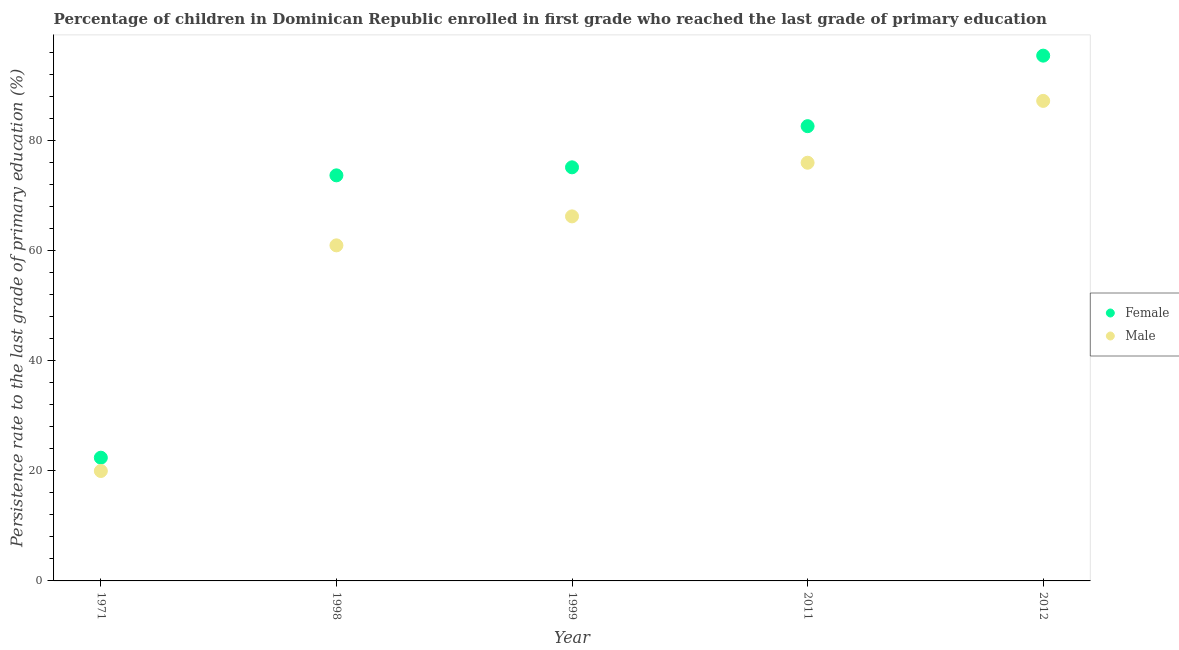What is the persistence rate of male students in 1971?
Keep it short and to the point. 19.98. Across all years, what is the maximum persistence rate of male students?
Provide a short and direct response. 87.27. Across all years, what is the minimum persistence rate of female students?
Provide a succinct answer. 22.4. In which year was the persistence rate of male students maximum?
Provide a succinct answer. 2012. What is the total persistence rate of male students in the graph?
Your response must be concise. 310.58. What is the difference between the persistence rate of female students in 1998 and that in 1999?
Make the answer very short. -1.46. What is the difference between the persistence rate of female students in 1999 and the persistence rate of male students in 1998?
Offer a terse response. 14.19. What is the average persistence rate of female students per year?
Ensure brevity in your answer.  69.9. In the year 1998, what is the difference between the persistence rate of male students and persistence rate of female students?
Offer a very short reply. -12.73. What is the ratio of the persistence rate of male students in 1971 to that in 1999?
Your answer should be compact. 0.3. Is the persistence rate of female students in 1971 less than that in 2011?
Keep it short and to the point. Yes. What is the difference between the highest and the second highest persistence rate of female students?
Make the answer very short. 12.82. What is the difference between the highest and the lowest persistence rate of female students?
Your answer should be compact. 73.1. Is the persistence rate of male students strictly greater than the persistence rate of female students over the years?
Your answer should be compact. No. Is the persistence rate of female students strictly less than the persistence rate of male students over the years?
Keep it short and to the point. No. How many years are there in the graph?
Ensure brevity in your answer.  5. Does the graph contain any zero values?
Provide a short and direct response. No. Does the graph contain grids?
Make the answer very short. No. Where does the legend appear in the graph?
Offer a terse response. Center right. How are the legend labels stacked?
Provide a succinct answer. Vertical. What is the title of the graph?
Offer a terse response. Percentage of children in Dominican Republic enrolled in first grade who reached the last grade of primary education. What is the label or title of the X-axis?
Make the answer very short. Year. What is the label or title of the Y-axis?
Give a very brief answer. Persistence rate to the last grade of primary education (%). What is the Persistence rate to the last grade of primary education (%) in Female in 1971?
Ensure brevity in your answer.  22.4. What is the Persistence rate to the last grade of primary education (%) of Male in 1971?
Provide a short and direct response. 19.98. What is the Persistence rate to the last grade of primary education (%) in Female in 1998?
Provide a short and direct response. 73.74. What is the Persistence rate to the last grade of primary education (%) of Male in 1998?
Your answer should be compact. 61.01. What is the Persistence rate to the last grade of primary education (%) of Female in 1999?
Your response must be concise. 75.2. What is the Persistence rate to the last grade of primary education (%) of Male in 1999?
Your answer should be very brief. 66.28. What is the Persistence rate to the last grade of primary education (%) of Female in 2011?
Your response must be concise. 82.68. What is the Persistence rate to the last grade of primary education (%) of Male in 2011?
Your response must be concise. 76.03. What is the Persistence rate to the last grade of primary education (%) of Female in 2012?
Give a very brief answer. 95.5. What is the Persistence rate to the last grade of primary education (%) of Male in 2012?
Offer a terse response. 87.27. Across all years, what is the maximum Persistence rate to the last grade of primary education (%) of Female?
Your response must be concise. 95.5. Across all years, what is the maximum Persistence rate to the last grade of primary education (%) of Male?
Your answer should be compact. 87.27. Across all years, what is the minimum Persistence rate to the last grade of primary education (%) in Female?
Make the answer very short. 22.4. Across all years, what is the minimum Persistence rate to the last grade of primary education (%) in Male?
Provide a succinct answer. 19.98. What is the total Persistence rate to the last grade of primary education (%) in Female in the graph?
Give a very brief answer. 349.51. What is the total Persistence rate to the last grade of primary education (%) in Male in the graph?
Provide a succinct answer. 310.58. What is the difference between the Persistence rate to the last grade of primary education (%) in Female in 1971 and that in 1998?
Offer a very short reply. -51.33. What is the difference between the Persistence rate to the last grade of primary education (%) of Male in 1971 and that in 1998?
Offer a terse response. -41.03. What is the difference between the Persistence rate to the last grade of primary education (%) in Female in 1971 and that in 1999?
Your response must be concise. -52.79. What is the difference between the Persistence rate to the last grade of primary education (%) in Male in 1971 and that in 1999?
Ensure brevity in your answer.  -46.3. What is the difference between the Persistence rate to the last grade of primary education (%) in Female in 1971 and that in 2011?
Keep it short and to the point. -60.27. What is the difference between the Persistence rate to the last grade of primary education (%) of Male in 1971 and that in 2011?
Your answer should be very brief. -56.05. What is the difference between the Persistence rate to the last grade of primary education (%) of Female in 1971 and that in 2012?
Provide a short and direct response. -73.1. What is the difference between the Persistence rate to the last grade of primary education (%) of Male in 1971 and that in 2012?
Your answer should be compact. -67.29. What is the difference between the Persistence rate to the last grade of primary education (%) of Female in 1998 and that in 1999?
Your response must be concise. -1.46. What is the difference between the Persistence rate to the last grade of primary education (%) in Male in 1998 and that in 1999?
Offer a terse response. -5.27. What is the difference between the Persistence rate to the last grade of primary education (%) of Female in 1998 and that in 2011?
Make the answer very short. -8.94. What is the difference between the Persistence rate to the last grade of primary education (%) in Male in 1998 and that in 2011?
Your answer should be compact. -15.02. What is the difference between the Persistence rate to the last grade of primary education (%) in Female in 1998 and that in 2012?
Provide a succinct answer. -21.76. What is the difference between the Persistence rate to the last grade of primary education (%) in Male in 1998 and that in 2012?
Provide a succinct answer. -26.26. What is the difference between the Persistence rate to the last grade of primary education (%) in Female in 1999 and that in 2011?
Offer a very short reply. -7.48. What is the difference between the Persistence rate to the last grade of primary education (%) of Male in 1999 and that in 2011?
Provide a succinct answer. -9.75. What is the difference between the Persistence rate to the last grade of primary education (%) of Female in 1999 and that in 2012?
Give a very brief answer. -20.3. What is the difference between the Persistence rate to the last grade of primary education (%) in Male in 1999 and that in 2012?
Offer a very short reply. -20.99. What is the difference between the Persistence rate to the last grade of primary education (%) in Female in 2011 and that in 2012?
Give a very brief answer. -12.82. What is the difference between the Persistence rate to the last grade of primary education (%) in Male in 2011 and that in 2012?
Your answer should be compact. -11.24. What is the difference between the Persistence rate to the last grade of primary education (%) in Female in 1971 and the Persistence rate to the last grade of primary education (%) in Male in 1998?
Give a very brief answer. -38.6. What is the difference between the Persistence rate to the last grade of primary education (%) of Female in 1971 and the Persistence rate to the last grade of primary education (%) of Male in 1999?
Make the answer very short. -43.87. What is the difference between the Persistence rate to the last grade of primary education (%) of Female in 1971 and the Persistence rate to the last grade of primary education (%) of Male in 2011?
Offer a very short reply. -53.63. What is the difference between the Persistence rate to the last grade of primary education (%) of Female in 1971 and the Persistence rate to the last grade of primary education (%) of Male in 2012?
Your response must be concise. -64.87. What is the difference between the Persistence rate to the last grade of primary education (%) in Female in 1998 and the Persistence rate to the last grade of primary education (%) in Male in 1999?
Ensure brevity in your answer.  7.46. What is the difference between the Persistence rate to the last grade of primary education (%) in Female in 1998 and the Persistence rate to the last grade of primary education (%) in Male in 2011?
Keep it short and to the point. -2.29. What is the difference between the Persistence rate to the last grade of primary education (%) of Female in 1998 and the Persistence rate to the last grade of primary education (%) of Male in 2012?
Make the answer very short. -13.54. What is the difference between the Persistence rate to the last grade of primary education (%) of Female in 1999 and the Persistence rate to the last grade of primary education (%) of Male in 2011?
Your answer should be compact. -0.84. What is the difference between the Persistence rate to the last grade of primary education (%) in Female in 1999 and the Persistence rate to the last grade of primary education (%) in Male in 2012?
Ensure brevity in your answer.  -12.08. What is the difference between the Persistence rate to the last grade of primary education (%) in Female in 2011 and the Persistence rate to the last grade of primary education (%) in Male in 2012?
Keep it short and to the point. -4.59. What is the average Persistence rate to the last grade of primary education (%) in Female per year?
Keep it short and to the point. 69.9. What is the average Persistence rate to the last grade of primary education (%) in Male per year?
Your answer should be compact. 62.12. In the year 1971, what is the difference between the Persistence rate to the last grade of primary education (%) of Female and Persistence rate to the last grade of primary education (%) of Male?
Give a very brief answer. 2.42. In the year 1998, what is the difference between the Persistence rate to the last grade of primary education (%) in Female and Persistence rate to the last grade of primary education (%) in Male?
Keep it short and to the point. 12.73. In the year 1999, what is the difference between the Persistence rate to the last grade of primary education (%) of Female and Persistence rate to the last grade of primary education (%) of Male?
Provide a succinct answer. 8.92. In the year 2011, what is the difference between the Persistence rate to the last grade of primary education (%) of Female and Persistence rate to the last grade of primary education (%) of Male?
Your response must be concise. 6.65. In the year 2012, what is the difference between the Persistence rate to the last grade of primary education (%) of Female and Persistence rate to the last grade of primary education (%) of Male?
Your response must be concise. 8.23. What is the ratio of the Persistence rate to the last grade of primary education (%) of Female in 1971 to that in 1998?
Ensure brevity in your answer.  0.3. What is the ratio of the Persistence rate to the last grade of primary education (%) of Male in 1971 to that in 1998?
Ensure brevity in your answer.  0.33. What is the ratio of the Persistence rate to the last grade of primary education (%) of Female in 1971 to that in 1999?
Keep it short and to the point. 0.3. What is the ratio of the Persistence rate to the last grade of primary education (%) of Male in 1971 to that in 1999?
Keep it short and to the point. 0.3. What is the ratio of the Persistence rate to the last grade of primary education (%) of Female in 1971 to that in 2011?
Provide a short and direct response. 0.27. What is the ratio of the Persistence rate to the last grade of primary education (%) of Male in 1971 to that in 2011?
Make the answer very short. 0.26. What is the ratio of the Persistence rate to the last grade of primary education (%) of Female in 1971 to that in 2012?
Give a very brief answer. 0.23. What is the ratio of the Persistence rate to the last grade of primary education (%) in Male in 1971 to that in 2012?
Your response must be concise. 0.23. What is the ratio of the Persistence rate to the last grade of primary education (%) of Female in 1998 to that in 1999?
Ensure brevity in your answer.  0.98. What is the ratio of the Persistence rate to the last grade of primary education (%) of Male in 1998 to that in 1999?
Ensure brevity in your answer.  0.92. What is the ratio of the Persistence rate to the last grade of primary education (%) of Female in 1998 to that in 2011?
Offer a terse response. 0.89. What is the ratio of the Persistence rate to the last grade of primary education (%) in Male in 1998 to that in 2011?
Provide a succinct answer. 0.8. What is the ratio of the Persistence rate to the last grade of primary education (%) in Female in 1998 to that in 2012?
Provide a succinct answer. 0.77. What is the ratio of the Persistence rate to the last grade of primary education (%) of Male in 1998 to that in 2012?
Your response must be concise. 0.7. What is the ratio of the Persistence rate to the last grade of primary education (%) in Female in 1999 to that in 2011?
Your answer should be compact. 0.91. What is the ratio of the Persistence rate to the last grade of primary education (%) of Male in 1999 to that in 2011?
Your answer should be very brief. 0.87. What is the ratio of the Persistence rate to the last grade of primary education (%) of Female in 1999 to that in 2012?
Your answer should be compact. 0.79. What is the ratio of the Persistence rate to the last grade of primary education (%) in Male in 1999 to that in 2012?
Make the answer very short. 0.76. What is the ratio of the Persistence rate to the last grade of primary education (%) of Female in 2011 to that in 2012?
Offer a terse response. 0.87. What is the ratio of the Persistence rate to the last grade of primary education (%) in Male in 2011 to that in 2012?
Keep it short and to the point. 0.87. What is the difference between the highest and the second highest Persistence rate to the last grade of primary education (%) in Female?
Ensure brevity in your answer.  12.82. What is the difference between the highest and the second highest Persistence rate to the last grade of primary education (%) of Male?
Give a very brief answer. 11.24. What is the difference between the highest and the lowest Persistence rate to the last grade of primary education (%) of Female?
Keep it short and to the point. 73.1. What is the difference between the highest and the lowest Persistence rate to the last grade of primary education (%) of Male?
Make the answer very short. 67.29. 